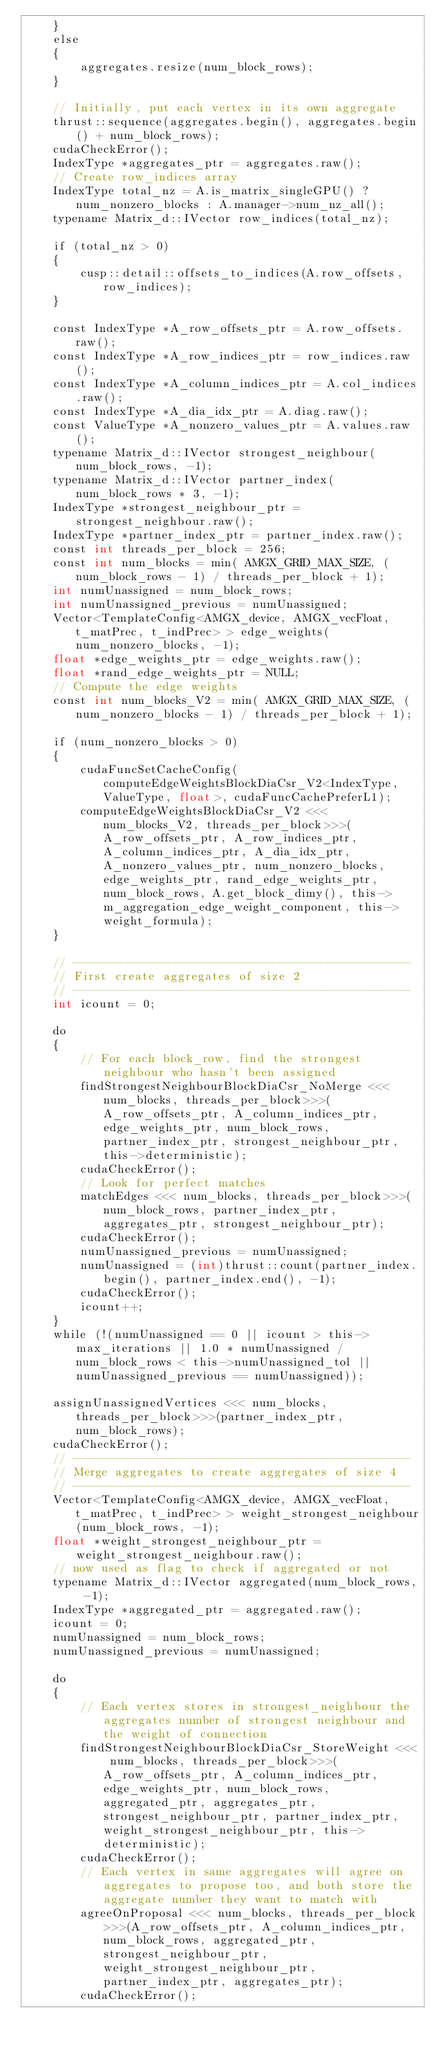Convert code to text. <code><loc_0><loc_0><loc_500><loc_500><_Cuda_>    }
    else
    {
        aggregates.resize(num_block_rows);
    }

    // Initially, put each vertex in its own aggregate
    thrust::sequence(aggregates.begin(), aggregates.begin() + num_block_rows);
    cudaCheckError();
    IndexType *aggregates_ptr = aggregates.raw();
    // Create row_indices array
    IndexType total_nz = A.is_matrix_singleGPU() ? num_nonzero_blocks : A.manager->num_nz_all();
    typename Matrix_d::IVector row_indices(total_nz);

    if (total_nz > 0)
    {
        cusp::detail::offsets_to_indices(A.row_offsets, row_indices);
    }

    const IndexType *A_row_offsets_ptr = A.row_offsets.raw();
    const IndexType *A_row_indices_ptr = row_indices.raw();
    const IndexType *A_column_indices_ptr = A.col_indices.raw();
    const IndexType *A_dia_idx_ptr = A.diag.raw();
    const ValueType *A_nonzero_values_ptr = A.values.raw();
    typename Matrix_d::IVector strongest_neighbour(num_block_rows, -1);
    typename Matrix_d::IVector partner_index(num_block_rows * 3, -1);
    IndexType *strongest_neighbour_ptr = strongest_neighbour.raw();
    IndexType *partner_index_ptr = partner_index.raw();
    const int threads_per_block = 256;
    const int num_blocks = min( AMGX_GRID_MAX_SIZE, (num_block_rows - 1) / threads_per_block + 1);
    int numUnassigned = num_block_rows;
    int numUnassigned_previous = numUnassigned;
    Vector<TemplateConfig<AMGX_device, AMGX_vecFloat, t_matPrec, t_indPrec> > edge_weights(num_nonzero_blocks, -1);
    float *edge_weights_ptr = edge_weights.raw();
    float *rand_edge_weights_ptr = NULL;
    // Compute the edge weights
    const int num_blocks_V2 = min( AMGX_GRID_MAX_SIZE, (num_nonzero_blocks - 1) / threads_per_block + 1);

    if (num_nonzero_blocks > 0)
    {
        cudaFuncSetCacheConfig(computeEdgeWeightsBlockDiaCsr_V2<IndexType, ValueType, float>, cudaFuncCachePreferL1);
        computeEdgeWeightsBlockDiaCsr_V2 <<< num_blocks_V2, threads_per_block>>>(A_row_offsets_ptr, A_row_indices_ptr, A_column_indices_ptr, A_dia_idx_ptr, A_nonzero_values_ptr, num_nonzero_blocks, edge_weights_ptr, rand_edge_weights_ptr, num_block_rows, A.get_block_dimy(), this->m_aggregation_edge_weight_component, this->weight_formula);
    }

    // -------------------------------------------------
    // First create aggregates of size 2
    // -------------------------------------------------
    int icount = 0;

    do
    {
        // For each block_row, find the strongest neighbour who hasn't been assigned
        findStrongestNeighbourBlockDiaCsr_NoMerge <<< num_blocks, threads_per_block>>>(A_row_offsets_ptr, A_column_indices_ptr, edge_weights_ptr, num_block_rows, partner_index_ptr, strongest_neighbour_ptr, this->deterministic);
        cudaCheckError();
        // Look for perfect matches
        matchEdges <<< num_blocks, threads_per_block>>>(num_block_rows, partner_index_ptr, aggregates_ptr, strongest_neighbour_ptr);
        cudaCheckError();
        numUnassigned_previous = numUnassigned;
        numUnassigned = (int)thrust::count(partner_index.begin(), partner_index.end(), -1);
        cudaCheckError();
        icount++;
    }
    while (!(numUnassigned == 0 || icount > this->max_iterations || 1.0 * numUnassigned / num_block_rows < this->numUnassigned_tol || numUnassigned_previous == numUnassigned));

    assignUnassignedVertices <<< num_blocks, threads_per_block>>>(partner_index_ptr, num_block_rows);
    cudaCheckError();
    // -------------------------------------------------
    // Merge aggregates to create aggregates of size 4
    // -------------------------------------------------
    Vector<TemplateConfig<AMGX_device, AMGX_vecFloat, t_matPrec, t_indPrec> > weight_strongest_neighbour(num_block_rows, -1);
    float *weight_strongest_neighbour_ptr = weight_strongest_neighbour.raw();
    // now used as flag to check if aggregated or not
    typename Matrix_d::IVector aggregated(num_block_rows, -1);
    IndexType *aggregated_ptr = aggregated.raw();
    icount = 0;
    numUnassigned = num_block_rows;
    numUnassigned_previous = numUnassigned;

    do
    {
        // Each vertex stores in strongest_neighbour the aggregates number of strongest neighbour and the weight of connection
        findStrongestNeighbourBlockDiaCsr_StoreWeight <<< num_blocks, threads_per_block>>>(A_row_offsets_ptr, A_column_indices_ptr, edge_weights_ptr, num_block_rows, aggregated_ptr, aggregates_ptr, strongest_neighbour_ptr, partner_index_ptr, weight_strongest_neighbour_ptr, this->deterministic);
        cudaCheckError();
        // Each vertex in same aggregates will agree on aggregates to propose too, and both store the aggregate number they want to match with
        agreeOnProposal <<< num_blocks, threads_per_block>>>(A_row_offsets_ptr, A_column_indices_ptr, num_block_rows, aggregated_ptr, strongest_neighbour_ptr, weight_strongest_neighbour_ptr, partner_index_ptr, aggregates_ptr);
        cudaCheckError();</code> 